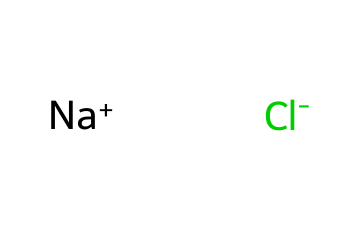What is the molecular formula of road salt? The molecular formula is determined by identifying the elements present in the SMILES representation. Sodium (Na) and chlorine (Cl) are identified, leading to the formula NaCl.
Answer: NaCl How many atoms are present in sodium chloride? The SMILES indicates one sodium ion and one chloride ion, leading to a total of two distinct atoms in the compound.
Answer: 2 What ion has a positive charge in the chemical? The SMILES shows [Na+] indicating that sodium has a positive charge. This suggests sodium is in the cation form.
Answer: Sodium What type of bond exists between sodium and chloride? Sodium chloride is formed through ionic bonding, where electrons are transferred from sodium to chlorine. This can be inferred from the presence of a positively charged sodium ion and a negatively charged chloride ion.
Answer: Ionic bond What is the total charge of sodium chloride when dissolved in water? In aqueous solutions, sodium chloride dissociates into Na+ and Cl-. Each of these ions has a charge of either +1 or -1, respectively, leading to a total charge of zero for the compound in solution.
Answer: 0 What type of electrolyte is sodium chloride? Sodium chloride is classified as a strong electrolyte because it completely dissociates into its ions in solution, allowing for effective electrical conductivity.
Answer: Strong electrolyte How does the presence of sodium chloride affect freezing point? Sodium chloride lowers the freezing point of water when solubilized, a property known as freezing point depression, due to the disruption of the water's structure by the ions.
Answer: Lowers freezing point 